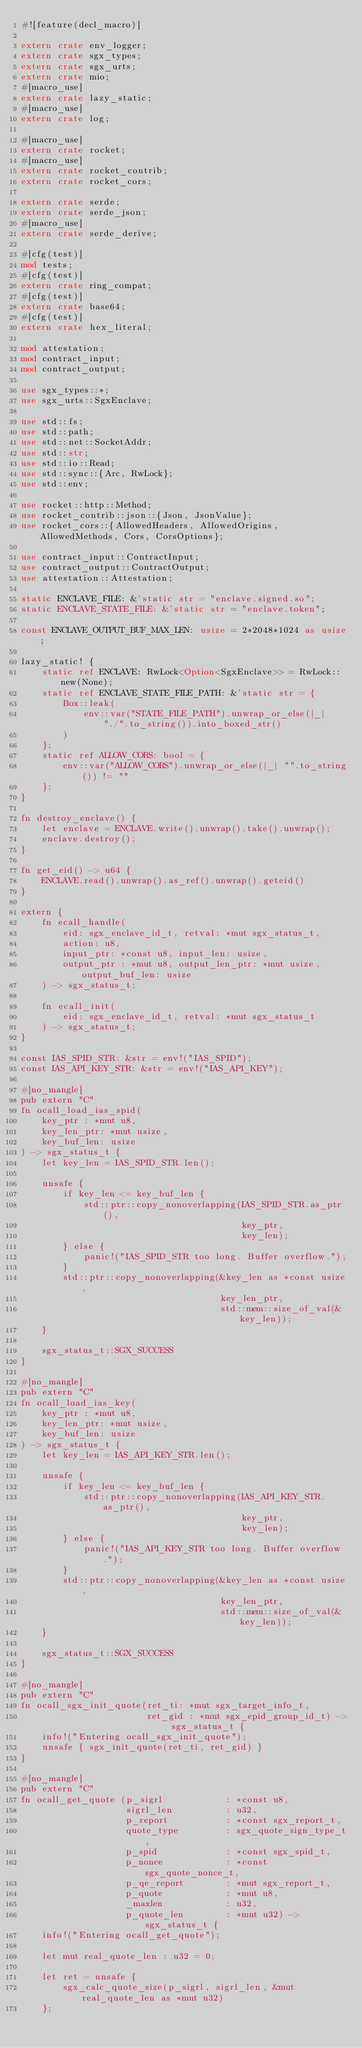<code> <loc_0><loc_0><loc_500><loc_500><_Rust_>#![feature(decl_macro)]

extern crate env_logger;
extern crate sgx_types;
extern crate sgx_urts;
extern crate mio;
#[macro_use]
extern crate lazy_static;
#[macro_use]
extern crate log;

#[macro_use]
extern crate rocket;
#[macro_use]
extern crate rocket_contrib;
extern crate rocket_cors;

extern crate serde;
extern crate serde_json;
#[macro_use]
extern crate serde_derive;

#[cfg(test)]
mod tests;
#[cfg(test)]
extern crate ring_compat;
#[cfg(test)]
extern crate base64;
#[cfg(test)]
extern crate hex_literal;

mod attestation;
mod contract_input;
mod contract_output;

use sgx_types::*;
use sgx_urts::SgxEnclave;

use std::fs;
use std::path;
use std::net::SocketAddr;
use std::str;
use std::io::Read;
use std::sync::{Arc, RwLock};
use std::env;

use rocket::http::Method;
use rocket_contrib::json::{Json, JsonValue};
use rocket_cors::{AllowedHeaders, AllowedOrigins, AllowedMethods, Cors, CorsOptions};

use contract_input::ContractInput;
use contract_output::ContractOutput;
use attestation::Attestation;

static ENCLAVE_FILE: &'static str = "enclave.signed.so";
static ENCLAVE_STATE_FILE: &'static str = "enclave.token";

const ENCLAVE_OUTPUT_BUF_MAX_LEN: usize = 2*2048*1024 as usize;

lazy_static! {
    static ref ENCLAVE: RwLock<Option<SgxEnclave>> = RwLock::new(None);
    static ref ENCLAVE_STATE_FILE_PATH: &'static str = {
        Box::leak(
            env::var("STATE_FILE_PATH").unwrap_or_else(|_| "./".to_string()).into_boxed_str()
        )
    };
    static ref ALLOW_CORS: bool = {
        env::var("ALLOW_CORS").unwrap_or_else(|_| "".to_string()) != ""
    };
}

fn destroy_enclave() {
    let enclave = ENCLAVE.write().unwrap().take().unwrap();
    enclave.destroy();
}

fn get_eid() -> u64 {
    ENCLAVE.read().unwrap().as_ref().unwrap().geteid()
}

extern {
    fn ecall_handle(
        eid: sgx_enclave_id_t, retval: *mut sgx_status_t,
        action: u8,
        input_ptr: *const u8, input_len: usize,
        output_ptr : *mut u8, output_len_ptr: *mut usize, output_buf_len: usize
    ) -> sgx_status_t;

    fn ecall_init(
        eid: sgx_enclave_id_t, retval: *mut sgx_status_t
    ) -> sgx_status_t;
}

const IAS_SPID_STR: &str = env!("IAS_SPID");
const IAS_API_KEY_STR: &str = env!("IAS_API_KEY");

#[no_mangle]
pub extern "C"
fn ocall_load_ias_spid(
    key_ptr : *mut u8,
    key_len_ptr: *mut usize,
    key_buf_len: usize
) -> sgx_status_t {
    let key_len = IAS_SPID_STR.len();

    unsafe {
        if key_len <= key_buf_len {
            std::ptr::copy_nonoverlapping(IAS_SPID_STR.as_ptr(),
                                          key_ptr,
                                          key_len);
        } else {
            panic!("IAS_SPID_STR too long. Buffer overflow.");
        }
        std::ptr::copy_nonoverlapping(&key_len as *const usize,
                                      key_len_ptr,
                                      std::mem::size_of_val(&key_len));
    }

    sgx_status_t::SGX_SUCCESS
}

#[no_mangle]
pub extern "C"
fn ocall_load_ias_key(
    key_ptr : *mut u8,
    key_len_ptr: *mut usize,
    key_buf_len: usize
) -> sgx_status_t {
    let key_len = IAS_API_KEY_STR.len();

    unsafe {
        if key_len <= key_buf_len {
            std::ptr::copy_nonoverlapping(IAS_API_KEY_STR.as_ptr(),
                                          key_ptr,
                                          key_len);
        } else {
            panic!("IAS_API_KEY_STR too long. Buffer overflow.");
        }
        std::ptr::copy_nonoverlapping(&key_len as *const usize,
                                      key_len_ptr,
                                      std::mem::size_of_val(&key_len));
    }

    sgx_status_t::SGX_SUCCESS
}

#[no_mangle]
pub extern "C"
fn ocall_sgx_init_quote(ret_ti: *mut sgx_target_info_t,
                        ret_gid : *mut sgx_epid_group_id_t) -> sgx_status_t {
    info!("Entering ocall_sgx_init_quote");
    unsafe { sgx_init_quote(ret_ti, ret_gid) }
}

#[no_mangle]
pub extern "C"
fn ocall_get_quote (p_sigrl            : *const u8,
                    sigrl_len          : u32,
                    p_report           : *const sgx_report_t,
                    quote_type         : sgx_quote_sign_type_t,
                    p_spid             : *const sgx_spid_t,
                    p_nonce            : *const sgx_quote_nonce_t,
                    p_qe_report        : *mut sgx_report_t,
                    p_quote            : *mut u8,
                    _maxlen            : u32,
                    p_quote_len        : *mut u32) -> sgx_status_t {
    info!("Entering ocall_get_quote");

    let mut real_quote_len : u32 = 0;

    let ret = unsafe {
        sgx_calc_quote_size(p_sigrl, sigrl_len, &mut real_quote_len as *mut u32)
    };
</code> 